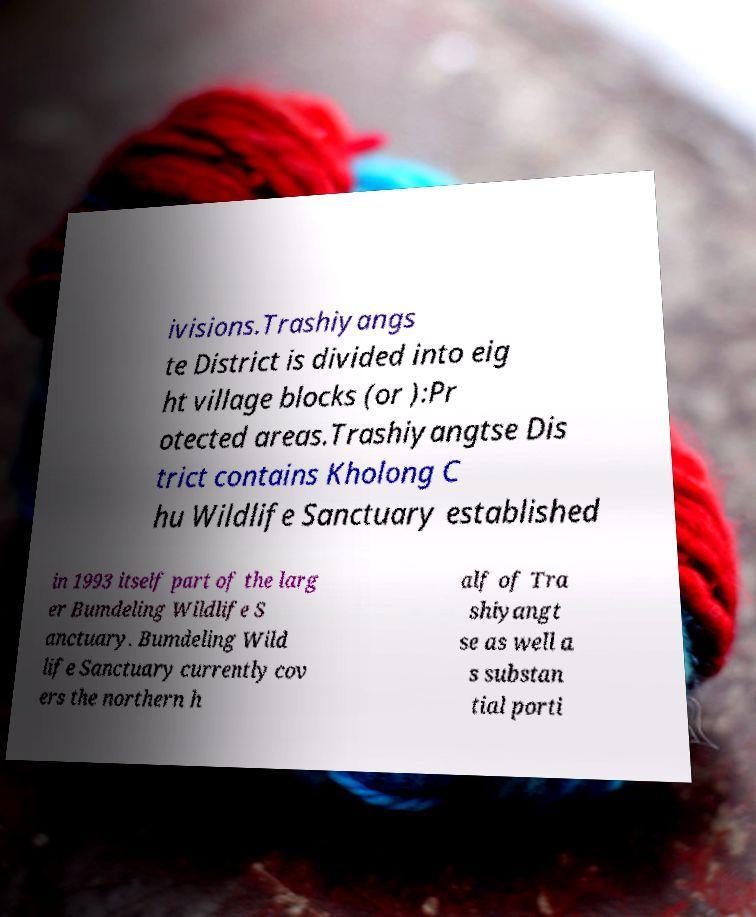There's text embedded in this image that I need extracted. Can you transcribe it verbatim? ivisions.Trashiyangs te District is divided into eig ht village blocks (or ):Pr otected areas.Trashiyangtse Dis trict contains Kholong C hu Wildlife Sanctuary established in 1993 itself part of the larg er Bumdeling Wildlife S anctuary. Bumdeling Wild life Sanctuary currently cov ers the northern h alf of Tra shiyangt se as well a s substan tial porti 